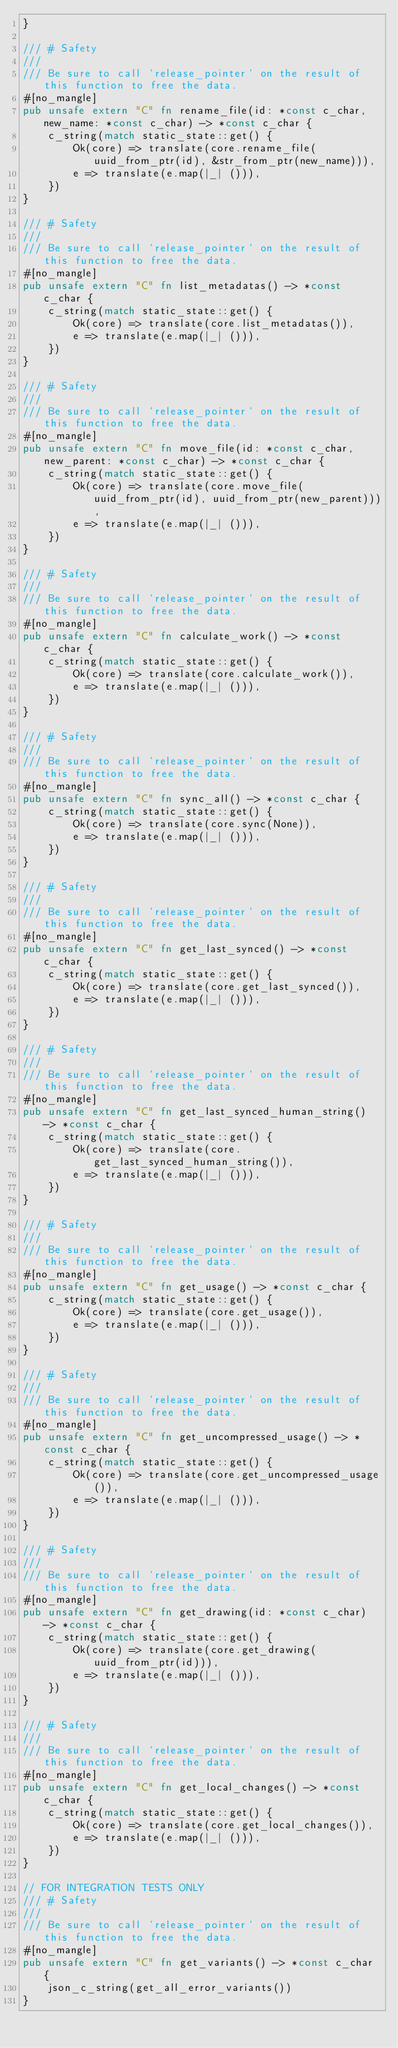Convert code to text. <code><loc_0><loc_0><loc_500><loc_500><_Rust_>}

/// # Safety
///
/// Be sure to call `release_pointer` on the result of this function to free the data.
#[no_mangle]
pub unsafe extern "C" fn rename_file(id: *const c_char, new_name: *const c_char) -> *const c_char {
    c_string(match static_state::get() {
        Ok(core) => translate(core.rename_file(uuid_from_ptr(id), &str_from_ptr(new_name))),
        e => translate(e.map(|_| ())),
    })
}

/// # Safety
///
/// Be sure to call `release_pointer` on the result of this function to free the data.
#[no_mangle]
pub unsafe extern "C" fn list_metadatas() -> *const c_char {
    c_string(match static_state::get() {
        Ok(core) => translate(core.list_metadatas()),
        e => translate(e.map(|_| ())),
    })
}

/// # Safety
///
/// Be sure to call `release_pointer` on the result of this function to free the data.
#[no_mangle]
pub unsafe extern "C" fn move_file(id: *const c_char, new_parent: *const c_char) -> *const c_char {
    c_string(match static_state::get() {
        Ok(core) => translate(core.move_file(uuid_from_ptr(id), uuid_from_ptr(new_parent))),
        e => translate(e.map(|_| ())),
    })
}

/// # Safety
///
/// Be sure to call `release_pointer` on the result of this function to free the data.
#[no_mangle]
pub unsafe extern "C" fn calculate_work() -> *const c_char {
    c_string(match static_state::get() {
        Ok(core) => translate(core.calculate_work()),
        e => translate(e.map(|_| ())),
    })
}

/// # Safety
///
/// Be sure to call `release_pointer` on the result of this function to free the data.
#[no_mangle]
pub unsafe extern "C" fn sync_all() -> *const c_char {
    c_string(match static_state::get() {
        Ok(core) => translate(core.sync(None)),
        e => translate(e.map(|_| ())),
    })
}

/// # Safety
///
/// Be sure to call `release_pointer` on the result of this function to free the data.
#[no_mangle]
pub unsafe extern "C" fn get_last_synced() -> *const c_char {
    c_string(match static_state::get() {
        Ok(core) => translate(core.get_last_synced()),
        e => translate(e.map(|_| ())),
    })
}

/// # Safety
///
/// Be sure to call `release_pointer` on the result of this function to free the data.
#[no_mangle]
pub unsafe extern "C" fn get_last_synced_human_string() -> *const c_char {
    c_string(match static_state::get() {
        Ok(core) => translate(core.get_last_synced_human_string()),
        e => translate(e.map(|_| ())),
    })
}

/// # Safety
///
/// Be sure to call `release_pointer` on the result of this function to free the data.
#[no_mangle]
pub unsafe extern "C" fn get_usage() -> *const c_char {
    c_string(match static_state::get() {
        Ok(core) => translate(core.get_usage()),
        e => translate(e.map(|_| ())),
    })
}

/// # Safety
///
/// Be sure to call `release_pointer` on the result of this function to free the data.
#[no_mangle]
pub unsafe extern "C" fn get_uncompressed_usage() -> *const c_char {
    c_string(match static_state::get() {
        Ok(core) => translate(core.get_uncompressed_usage()),
        e => translate(e.map(|_| ())),
    })
}

/// # Safety
///
/// Be sure to call `release_pointer` on the result of this function to free the data.
#[no_mangle]
pub unsafe extern "C" fn get_drawing(id: *const c_char) -> *const c_char {
    c_string(match static_state::get() {
        Ok(core) => translate(core.get_drawing(uuid_from_ptr(id))),
        e => translate(e.map(|_| ())),
    })
}

/// # Safety
///
/// Be sure to call `release_pointer` on the result of this function to free the data.
#[no_mangle]
pub unsafe extern "C" fn get_local_changes() -> *const c_char {
    c_string(match static_state::get() {
        Ok(core) => translate(core.get_local_changes()),
        e => translate(e.map(|_| ())),
    })
}

// FOR INTEGRATION TESTS ONLY
/// # Safety
///
/// Be sure to call `release_pointer` on the result of this function to free the data.
#[no_mangle]
pub unsafe extern "C" fn get_variants() -> *const c_char {
    json_c_string(get_all_error_variants())
}
</code> 